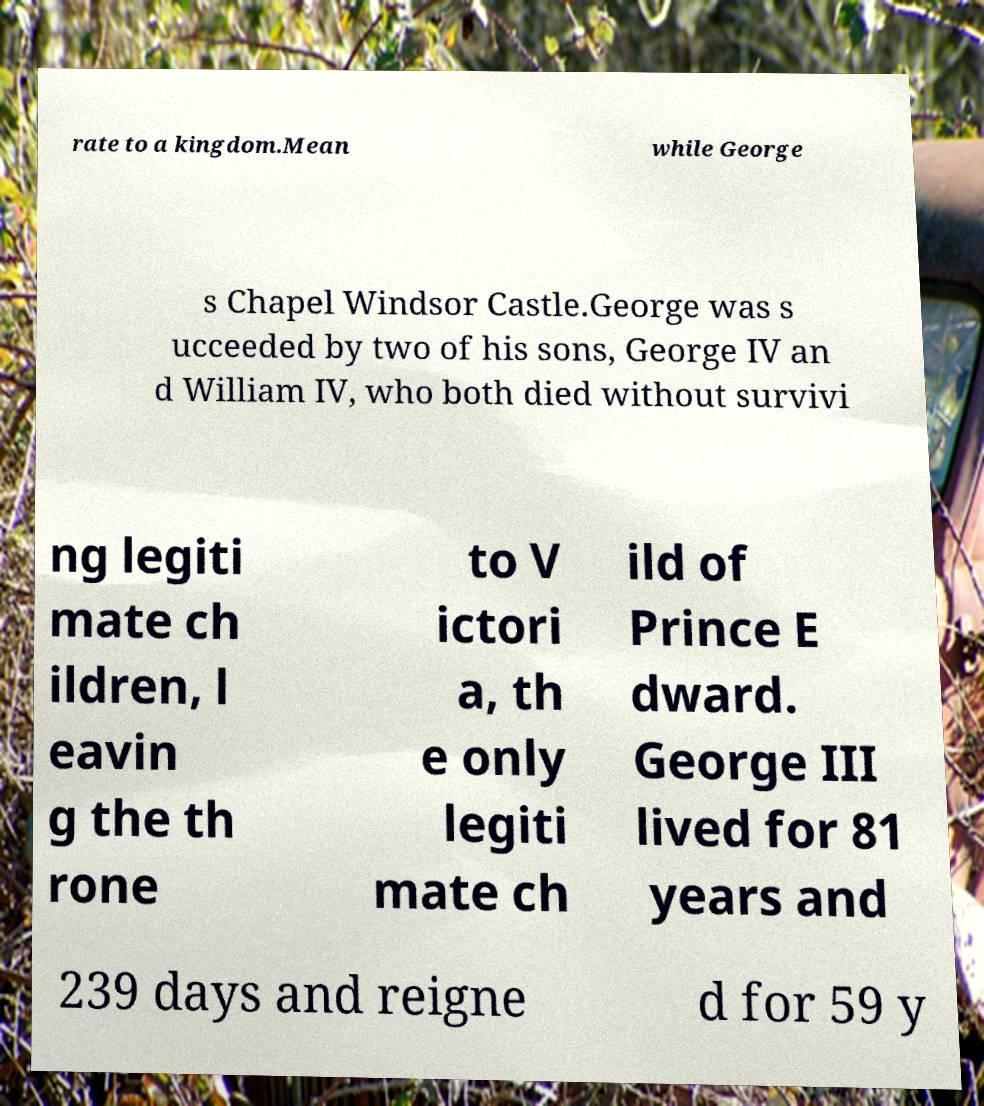Can you read and provide the text displayed in the image?This photo seems to have some interesting text. Can you extract and type it out for me? rate to a kingdom.Mean while George s Chapel Windsor Castle.George was s ucceeded by two of his sons, George IV an d William IV, who both died without survivi ng legiti mate ch ildren, l eavin g the th rone to V ictori a, th e only legiti mate ch ild of Prince E dward. George III lived for 81 years and 239 days and reigne d for 59 y 